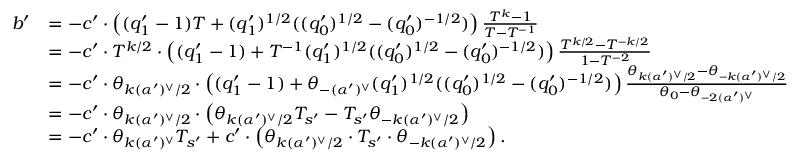<formula> <loc_0><loc_0><loc_500><loc_500>\begin{array} { r l } { b ^ { \prime } } & { = - c ^ { \prime } \cdot \left ( ( q _ { 1 } ^ { \prime } - 1 ) T + ( q _ { 1 } ^ { \prime } ) ^ { 1 / 2 } ( ( q _ { 0 } ^ { \prime } ) ^ { 1 / 2 } - ( q _ { 0 } ^ { \prime } ) ^ { - 1 / 2 } ) \right ) \frac { T ^ { k } - 1 } { T - T ^ { - 1 } } } \\ & { = - c ^ { \prime } \cdot T ^ { k / 2 } \cdot \left ( ( q _ { 1 } ^ { \prime } - 1 ) + T ^ { - 1 } ( q _ { 1 } ^ { \prime } ) ^ { 1 / 2 } ( ( q _ { 0 } ^ { \prime } ) ^ { 1 / 2 } - ( q _ { 0 } ^ { \prime } ) ^ { - 1 / 2 } ) \right ) \frac { T ^ { k / 2 } - T ^ { - k / 2 } } { 1 - T ^ { - 2 } } } \\ & { = - c ^ { \prime } \cdot \theta _ { k ( \alpha ^ { \prime } ) ^ { \vee } / 2 } \cdot \left ( ( q _ { 1 } ^ { \prime } - 1 ) + \theta _ { - ( \alpha ^ { \prime } ) ^ { \vee } } ( q _ { 1 } ^ { \prime } ) ^ { 1 / 2 } ( ( q _ { 0 } ^ { \prime } ) ^ { 1 / 2 } - ( q _ { 0 } ^ { \prime } ) ^ { - 1 / 2 } ) \right ) \frac { \theta _ { k ( \alpha ^ { \prime } ) ^ { \vee } / 2 } - \theta _ { - k ( \alpha ^ { \prime } ) ^ { \vee } / 2 } } { \theta _ { 0 } - \theta _ { - 2 ( \alpha ^ { \prime } ) ^ { \vee } } } } \\ & { = - c ^ { \prime } \cdot \theta _ { k ( \alpha ^ { \prime } ) ^ { \vee } / 2 } \cdot \left ( \theta _ { k ( \alpha ^ { \prime } ) ^ { \vee } / 2 } T _ { s ^ { \prime } } - T _ { s ^ { \prime } } \theta _ { - k ( \alpha ^ { \prime } ) ^ { \vee } / 2 } \right ) } \\ & { = - c ^ { \prime } \cdot \theta _ { k ( \alpha ^ { \prime } ) ^ { \vee } } T _ { s ^ { \prime } } + c ^ { \prime } \cdot \left ( \theta _ { k ( \alpha ^ { \prime } ) ^ { \vee } / 2 } \cdot T _ { s ^ { \prime } } \cdot \theta _ { - k ( \alpha ^ { \prime } ) ^ { \vee } / 2 } \right ) . } \end{array}</formula> 